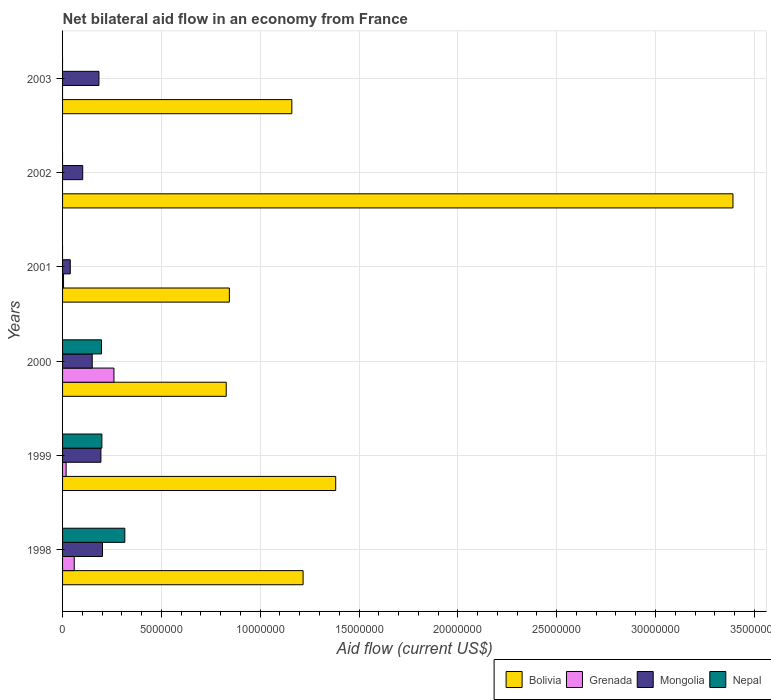How many groups of bars are there?
Give a very brief answer. 6. Are the number of bars per tick equal to the number of legend labels?
Ensure brevity in your answer.  No. How many bars are there on the 3rd tick from the top?
Keep it short and to the point. 3. Across all years, what is the maximum net bilateral aid flow in Grenada?
Keep it short and to the point. 2.60e+06. Across all years, what is the minimum net bilateral aid flow in Bolivia?
Offer a terse response. 8.28e+06. What is the total net bilateral aid flow in Bolivia in the graph?
Give a very brief answer. 8.82e+07. What is the difference between the net bilateral aid flow in Grenada in 1998 and the net bilateral aid flow in Nepal in 2003?
Keep it short and to the point. 5.90e+05. What is the average net bilateral aid flow in Nepal per year?
Provide a succinct answer. 1.18e+06. In the year 2002, what is the difference between the net bilateral aid flow in Bolivia and net bilateral aid flow in Mongolia?
Ensure brevity in your answer.  3.29e+07. In how many years, is the net bilateral aid flow in Grenada greater than 18000000 US$?
Offer a terse response. 0. What is the ratio of the net bilateral aid flow in Mongolia in 1998 to that in 2003?
Give a very brief answer. 1.1. Is the net bilateral aid flow in Mongolia in 2002 less than that in 2003?
Give a very brief answer. Yes. What is the difference between the highest and the second highest net bilateral aid flow in Bolivia?
Make the answer very short. 2.01e+07. What is the difference between the highest and the lowest net bilateral aid flow in Bolivia?
Your response must be concise. 2.56e+07. In how many years, is the net bilateral aid flow in Mongolia greater than the average net bilateral aid flow in Mongolia taken over all years?
Your response must be concise. 4. Is the sum of the net bilateral aid flow in Grenada in 1998 and 2001 greater than the maximum net bilateral aid flow in Bolivia across all years?
Give a very brief answer. No. Is it the case that in every year, the sum of the net bilateral aid flow in Mongolia and net bilateral aid flow in Nepal is greater than the sum of net bilateral aid flow in Bolivia and net bilateral aid flow in Grenada?
Your response must be concise. No. How many bars are there?
Your response must be concise. 19. Are all the bars in the graph horizontal?
Your answer should be compact. Yes. What is the difference between two consecutive major ticks on the X-axis?
Your response must be concise. 5.00e+06. Does the graph contain any zero values?
Your answer should be compact. Yes. Does the graph contain grids?
Offer a very short reply. Yes. Where does the legend appear in the graph?
Provide a succinct answer. Bottom right. What is the title of the graph?
Keep it short and to the point. Net bilateral aid flow in an economy from France. What is the Aid flow (current US$) of Bolivia in 1998?
Provide a short and direct response. 1.22e+07. What is the Aid flow (current US$) of Grenada in 1998?
Offer a very short reply. 5.90e+05. What is the Aid flow (current US$) in Mongolia in 1998?
Ensure brevity in your answer.  2.02e+06. What is the Aid flow (current US$) in Nepal in 1998?
Offer a very short reply. 3.15e+06. What is the Aid flow (current US$) of Bolivia in 1999?
Your response must be concise. 1.38e+07. What is the Aid flow (current US$) in Mongolia in 1999?
Your response must be concise. 1.94e+06. What is the Aid flow (current US$) in Nepal in 1999?
Your response must be concise. 1.99e+06. What is the Aid flow (current US$) of Bolivia in 2000?
Provide a succinct answer. 8.28e+06. What is the Aid flow (current US$) in Grenada in 2000?
Give a very brief answer. 2.60e+06. What is the Aid flow (current US$) of Mongolia in 2000?
Your response must be concise. 1.50e+06. What is the Aid flow (current US$) of Nepal in 2000?
Offer a very short reply. 1.97e+06. What is the Aid flow (current US$) of Bolivia in 2001?
Provide a short and direct response. 8.44e+06. What is the Aid flow (current US$) in Grenada in 2001?
Give a very brief answer. 5.00e+04. What is the Aid flow (current US$) of Mongolia in 2001?
Your answer should be compact. 3.90e+05. What is the Aid flow (current US$) of Bolivia in 2002?
Your answer should be compact. 3.39e+07. What is the Aid flow (current US$) in Grenada in 2002?
Keep it short and to the point. 0. What is the Aid flow (current US$) in Mongolia in 2002?
Keep it short and to the point. 1.02e+06. What is the Aid flow (current US$) in Bolivia in 2003?
Give a very brief answer. 1.16e+07. What is the Aid flow (current US$) in Grenada in 2003?
Give a very brief answer. 0. What is the Aid flow (current US$) of Mongolia in 2003?
Ensure brevity in your answer.  1.84e+06. Across all years, what is the maximum Aid flow (current US$) in Bolivia?
Your answer should be compact. 3.39e+07. Across all years, what is the maximum Aid flow (current US$) of Grenada?
Ensure brevity in your answer.  2.60e+06. Across all years, what is the maximum Aid flow (current US$) of Mongolia?
Make the answer very short. 2.02e+06. Across all years, what is the maximum Aid flow (current US$) of Nepal?
Ensure brevity in your answer.  3.15e+06. Across all years, what is the minimum Aid flow (current US$) in Bolivia?
Keep it short and to the point. 8.28e+06. Across all years, what is the minimum Aid flow (current US$) of Mongolia?
Give a very brief answer. 3.90e+05. What is the total Aid flow (current US$) in Bolivia in the graph?
Give a very brief answer. 8.82e+07. What is the total Aid flow (current US$) of Grenada in the graph?
Provide a succinct answer. 3.42e+06. What is the total Aid flow (current US$) of Mongolia in the graph?
Offer a very short reply. 8.71e+06. What is the total Aid flow (current US$) of Nepal in the graph?
Your answer should be compact. 7.11e+06. What is the difference between the Aid flow (current US$) of Bolivia in 1998 and that in 1999?
Your response must be concise. -1.65e+06. What is the difference between the Aid flow (current US$) in Mongolia in 1998 and that in 1999?
Provide a short and direct response. 8.00e+04. What is the difference between the Aid flow (current US$) of Nepal in 1998 and that in 1999?
Your response must be concise. 1.16e+06. What is the difference between the Aid flow (current US$) in Bolivia in 1998 and that in 2000?
Your answer should be compact. 3.89e+06. What is the difference between the Aid flow (current US$) of Grenada in 1998 and that in 2000?
Offer a very short reply. -2.01e+06. What is the difference between the Aid flow (current US$) in Mongolia in 1998 and that in 2000?
Provide a succinct answer. 5.20e+05. What is the difference between the Aid flow (current US$) in Nepal in 1998 and that in 2000?
Provide a succinct answer. 1.18e+06. What is the difference between the Aid flow (current US$) in Bolivia in 1998 and that in 2001?
Ensure brevity in your answer.  3.73e+06. What is the difference between the Aid flow (current US$) in Grenada in 1998 and that in 2001?
Offer a terse response. 5.40e+05. What is the difference between the Aid flow (current US$) in Mongolia in 1998 and that in 2001?
Keep it short and to the point. 1.63e+06. What is the difference between the Aid flow (current US$) in Bolivia in 1998 and that in 2002?
Your answer should be very brief. -2.18e+07. What is the difference between the Aid flow (current US$) in Mongolia in 1998 and that in 2002?
Give a very brief answer. 1.00e+06. What is the difference between the Aid flow (current US$) of Bolivia in 1998 and that in 2003?
Offer a terse response. 5.70e+05. What is the difference between the Aid flow (current US$) of Bolivia in 1999 and that in 2000?
Ensure brevity in your answer.  5.54e+06. What is the difference between the Aid flow (current US$) in Grenada in 1999 and that in 2000?
Offer a terse response. -2.42e+06. What is the difference between the Aid flow (current US$) in Nepal in 1999 and that in 2000?
Your answer should be compact. 2.00e+04. What is the difference between the Aid flow (current US$) in Bolivia in 1999 and that in 2001?
Give a very brief answer. 5.38e+06. What is the difference between the Aid flow (current US$) of Mongolia in 1999 and that in 2001?
Your response must be concise. 1.55e+06. What is the difference between the Aid flow (current US$) of Bolivia in 1999 and that in 2002?
Provide a succinct answer. -2.01e+07. What is the difference between the Aid flow (current US$) of Mongolia in 1999 and that in 2002?
Keep it short and to the point. 9.20e+05. What is the difference between the Aid flow (current US$) in Bolivia in 1999 and that in 2003?
Your response must be concise. 2.22e+06. What is the difference between the Aid flow (current US$) of Bolivia in 2000 and that in 2001?
Keep it short and to the point. -1.60e+05. What is the difference between the Aid flow (current US$) in Grenada in 2000 and that in 2001?
Keep it short and to the point. 2.55e+06. What is the difference between the Aid flow (current US$) of Mongolia in 2000 and that in 2001?
Offer a terse response. 1.11e+06. What is the difference between the Aid flow (current US$) of Bolivia in 2000 and that in 2002?
Make the answer very short. -2.56e+07. What is the difference between the Aid flow (current US$) in Mongolia in 2000 and that in 2002?
Ensure brevity in your answer.  4.80e+05. What is the difference between the Aid flow (current US$) in Bolivia in 2000 and that in 2003?
Your answer should be compact. -3.32e+06. What is the difference between the Aid flow (current US$) of Bolivia in 2001 and that in 2002?
Keep it short and to the point. -2.55e+07. What is the difference between the Aid flow (current US$) of Mongolia in 2001 and that in 2002?
Offer a terse response. -6.30e+05. What is the difference between the Aid flow (current US$) in Bolivia in 2001 and that in 2003?
Give a very brief answer. -3.16e+06. What is the difference between the Aid flow (current US$) of Mongolia in 2001 and that in 2003?
Ensure brevity in your answer.  -1.45e+06. What is the difference between the Aid flow (current US$) of Bolivia in 2002 and that in 2003?
Keep it short and to the point. 2.23e+07. What is the difference between the Aid flow (current US$) in Mongolia in 2002 and that in 2003?
Ensure brevity in your answer.  -8.20e+05. What is the difference between the Aid flow (current US$) of Bolivia in 1998 and the Aid flow (current US$) of Grenada in 1999?
Provide a succinct answer. 1.20e+07. What is the difference between the Aid flow (current US$) in Bolivia in 1998 and the Aid flow (current US$) in Mongolia in 1999?
Provide a short and direct response. 1.02e+07. What is the difference between the Aid flow (current US$) in Bolivia in 1998 and the Aid flow (current US$) in Nepal in 1999?
Your answer should be very brief. 1.02e+07. What is the difference between the Aid flow (current US$) in Grenada in 1998 and the Aid flow (current US$) in Mongolia in 1999?
Ensure brevity in your answer.  -1.35e+06. What is the difference between the Aid flow (current US$) in Grenada in 1998 and the Aid flow (current US$) in Nepal in 1999?
Ensure brevity in your answer.  -1.40e+06. What is the difference between the Aid flow (current US$) in Mongolia in 1998 and the Aid flow (current US$) in Nepal in 1999?
Give a very brief answer. 3.00e+04. What is the difference between the Aid flow (current US$) in Bolivia in 1998 and the Aid flow (current US$) in Grenada in 2000?
Provide a succinct answer. 9.57e+06. What is the difference between the Aid flow (current US$) in Bolivia in 1998 and the Aid flow (current US$) in Mongolia in 2000?
Your answer should be very brief. 1.07e+07. What is the difference between the Aid flow (current US$) in Bolivia in 1998 and the Aid flow (current US$) in Nepal in 2000?
Your answer should be very brief. 1.02e+07. What is the difference between the Aid flow (current US$) of Grenada in 1998 and the Aid flow (current US$) of Mongolia in 2000?
Your answer should be very brief. -9.10e+05. What is the difference between the Aid flow (current US$) of Grenada in 1998 and the Aid flow (current US$) of Nepal in 2000?
Your response must be concise. -1.38e+06. What is the difference between the Aid flow (current US$) in Mongolia in 1998 and the Aid flow (current US$) in Nepal in 2000?
Ensure brevity in your answer.  5.00e+04. What is the difference between the Aid flow (current US$) of Bolivia in 1998 and the Aid flow (current US$) of Grenada in 2001?
Provide a succinct answer. 1.21e+07. What is the difference between the Aid flow (current US$) of Bolivia in 1998 and the Aid flow (current US$) of Mongolia in 2001?
Ensure brevity in your answer.  1.18e+07. What is the difference between the Aid flow (current US$) in Bolivia in 1998 and the Aid flow (current US$) in Mongolia in 2002?
Your answer should be very brief. 1.12e+07. What is the difference between the Aid flow (current US$) of Grenada in 1998 and the Aid flow (current US$) of Mongolia in 2002?
Keep it short and to the point. -4.30e+05. What is the difference between the Aid flow (current US$) in Bolivia in 1998 and the Aid flow (current US$) in Mongolia in 2003?
Offer a terse response. 1.03e+07. What is the difference between the Aid flow (current US$) of Grenada in 1998 and the Aid flow (current US$) of Mongolia in 2003?
Your response must be concise. -1.25e+06. What is the difference between the Aid flow (current US$) in Bolivia in 1999 and the Aid flow (current US$) in Grenada in 2000?
Give a very brief answer. 1.12e+07. What is the difference between the Aid flow (current US$) of Bolivia in 1999 and the Aid flow (current US$) of Mongolia in 2000?
Make the answer very short. 1.23e+07. What is the difference between the Aid flow (current US$) of Bolivia in 1999 and the Aid flow (current US$) of Nepal in 2000?
Offer a very short reply. 1.18e+07. What is the difference between the Aid flow (current US$) in Grenada in 1999 and the Aid flow (current US$) in Mongolia in 2000?
Your answer should be compact. -1.32e+06. What is the difference between the Aid flow (current US$) of Grenada in 1999 and the Aid flow (current US$) of Nepal in 2000?
Your response must be concise. -1.79e+06. What is the difference between the Aid flow (current US$) in Bolivia in 1999 and the Aid flow (current US$) in Grenada in 2001?
Provide a short and direct response. 1.38e+07. What is the difference between the Aid flow (current US$) in Bolivia in 1999 and the Aid flow (current US$) in Mongolia in 2001?
Your answer should be very brief. 1.34e+07. What is the difference between the Aid flow (current US$) in Bolivia in 1999 and the Aid flow (current US$) in Mongolia in 2002?
Your response must be concise. 1.28e+07. What is the difference between the Aid flow (current US$) of Grenada in 1999 and the Aid flow (current US$) of Mongolia in 2002?
Your answer should be compact. -8.40e+05. What is the difference between the Aid flow (current US$) of Bolivia in 1999 and the Aid flow (current US$) of Mongolia in 2003?
Your answer should be very brief. 1.20e+07. What is the difference between the Aid flow (current US$) of Grenada in 1999 and the Aid flow (current US$) of Mongolia in 2003?
Offer a terse response. -1.66e+06. What is the difference between the Aid flow (current US$) in Bolivia in 2000 and the Aid flow (current US$) in Grenada in 2001?
Provide a short and direct response. 8.23e+06. What is the difference between the Aid flow (current US$) in Bolivia in 2000 and the Aid flow (current US$) in Mongolia in 2001?
Provide a short and direct response. 7.89e+06. What is the difference between the Aid flow (current US$) of Grenada in 2000 and the Aid flow (current US$) of Mongolia in 2001?
Offer a terse response. 2.21e+06. What is the difference between the Aid flow (current US$) in Bolivia in 2000 and the Aid flow (current US$) in Mongolia in 2002?
Offer a very short reply. 7.26e+06. What is the difference between the Aid flow (current US$) of Grenada in 2000 and the Aid flow (current US$) of Mongolia in 2002?
Your answer should be very brief. 1.58e+06. What is the difference between the Aid flow (current US$) in Bolivia in 2000 and the Aid flow (current US$) in Mongolia in 2003?
Offer a terse response. 6.44e+06. What is the difference between the Aid flow (current US$) in Grenada in 2000 and the Aid flow (current US$) in Mongolia in 2003?
Your answer should be compact. 7.60e+05. What is the difference between the Aid flow (current US$) of Bolivia in 2001 and the Aid flow (current US$) of Mongolia in 2002?
Provide a short and direct response. 7.42e+06. What is the difference between the Aid flow (current US$) of Grenada in 2001 and the Aid flow (current US$) of Mongolia in 2002?
Make the answer very short. -9.70e+05. What is the difference between the Aid flow (current US$) in Bolivia in 2001 and the Aid flow (current US$) in Mongolia in 2003?
Your answer should be compact. 6.60e+06. What is the difference between the Aid flow (current US$) of Grenada in 2001 and the Aid flow (current US$) of Mongolia in 2003?
Give a very brief answer. -1.79e+06. What is the difference between the Aid flow (current US$) of Bolivia in 2002 and the Aid flow (current US$) of Mongolia in 2003?
Provide a succinct answer. 3.21e+07. What is the average Aid flow (current US$) of Bolivia per year?
Offer a very short reply. 1.47e+07. What is the average Aid flow (current US$) of Grenada per year?
Your answer should be compact. 5.70e+05. What is the average Aid flow (current US$) in Mongolia per year?
Keep it short and to the point. 1.45e+06. What is the average Aid flow (current US$) in Nepal per year?
Make the answer very short. 1.18e+06. In the year 1998, what is the difference between the Aid flow (current US$) of Bolivia and Aid flow (current US$) of Grenada?
Make the answer very short. 1.16e+07. In the year 1998, what is the difference between the Aid flow (current US$) of Bolivia and Aid flow (current US$) of Mongolia?
Your answer should be very brief. 1.02e+07. In the year 1998, what is the difference between the Aid flow (current US$) of Bolivia and Aid flow (current US$) of Nepal?
Ensure brevity in your answer.  9.02e+06. In the year 1998, what is the difference between the Aid flow (current US$) of Grenada and Aid flow (current US$) of Mongolia?
Ensure brevity in your answer.  -1.43e+06. In the year 1998, what is the difference between the Aid flow (current US$) in Grenada and Aid flow (current US$) in Nepal?
Make the answer very short. -2.56e+06. In the year 1998, what is the difference between the Aid flow (current US$) of Mongolia and Aid flow (current US$) of Nepal?
Your answer should be very brief. -1.13e+06. In the year 1999, what is the difference between the Aid flow (current US$) of Bolivia and Aid flow (current US$) of Grenada?
Provide a succinct answer. 1.36e+07. In the year 1999, what is the difference between the Aid flow (current US$) in Bolivia and Aid flow (current US$) in Mongolia?
Ensure brevity in your answer.  1.19e+07. In the year 1999, what is the difference between the Aid flow (current US$) in Bolivia and Aid flow (current US$) in Nepal?
Give a very brief answer. 1.18e+07. In the year 1999, what is the difference between the Aid flow (current US$) of Grenada and Aid flow (current US$) of Mongolia?
Offer a terse response. -1.76e+06. In the year 1999, what is the difference between the Aid flow (current US$) of Grenada and Aid flow (current US$) of Nepal?
Your response must be concise. -1.81e+06. In the year 1999, what is the difference between the Aid flow (current US$) in Mongolia and Aid flow (current US$) in Nepal?
Give a very brief answer. -5.00e+04. In the year 2000, what is the difference between the Aid flow (current US$) of Bolivia and Aid flow (current US$) of Grenada?
Offer a terse response. 5.68e+06. In the year 2000, what is the difference between the Aid flow (current US$) of Bolivia and Aid flow (current US$) of Mongolia?
Your answer should be very brief. 6.78e+06. In the year 2000, what is the difference between the Aid flow (current US$) in Bolivia and Aid flow (current US$) in Nepal?
Offer a terse response. 6.31e+06. In the year 2000, what is the difference between the Aid flow (current US$) in Grenada and Aid flow (current US$) in Mongolia?
Your response must be concise. 1.10e+06. In the year 2000, what is the difference between the Aid flow (current US$) in Grenada and Aid flow (current US$) in Nepal?
Offer a terse response. 6.30e+05. In the year 2000, what is the difference between the Aid flow (current US$) in Mongolia and Aid flow (current US$) in Nepal?
Offer a very short reply. -4.70e+05. In the year 2001, what is the difference between the Aid flow (current US$) of Bolivia and Aid flow (current US$) of Grenada?
Give a very brief answer. 8.39e+06. In the year 2001, what is the difference between the Aid flow (current US$) in Bolivia and Aid flow (current US$) in Mongolia?
Your answer should be compact. 8.05e+06. In the year 2002, what is the difference between the Aid flow (current US$) in Bolivia and Aid flow (current US$) in Mongolia?
Make the answer very short. 3.29e+07. In the year 2003, what is the difference between the Aid flow (current US$) in Bolivia and Aid flow (current US$) in Mongolia?
Ensure brevity in your answer.  9.76e+06. What is the ratio of the Aid flow (current US$) of Bolivia in 1998 to that in 1999?
Provide a succinct answer. 0.88. What is the ratio of the Aid flow (current US$) in Grenada in 1998 to that in 1999?
Keep it short and to the point. 3.28. What is the ratio of the Aid flow (current US$) in Mongolia in 1998 to that in 1999?
Your response must be concise. 1.04. What is the ratio of the Aid flow (current US$) in Nepal in 1998 to that in 1999?
Offer a terse response. 1.58. What is the ratio of the Aid flow (current US$) in Bolivia in 1998 to that in 2000?
Make the answer very short. 1.47. What is the ratio of the Aid flow (current US$) of Grenada in 1998 to that in 2000?
Your answer should be very brief. 0.23. What is the ratio of the Aid flow (current US$) in Mongolia in 1998 to that in 2000?
Offer a terse response. 1.35. What is the ratio of the Aid flow (current US$) of Nepal in 1998 to that in 2000?
Your response must be concise. 1.6. What is the ratio of the Aid flow (current US$) of Bolivia in 1998 to that in 2001?
Give a very brief answer. 1.44. What is the ratio of the Aid flow (current US$) in Grenada in 1998 to that in 2001?
Offer a very short reply. 11.8. What is the ratio of the Aid flow (current US$) in Mongolia in 1998 to that in 2001?
Provide a succinct answer. 5.18. What is the ratio of the Aid flow (current US$) in Bolivia in 1998 to that in 2002?
Ensure brevity in your answer.  0.36. What is the ratio of the Aid flow (current US$) of Mongolia in 1998 to that in 2002?
Your answer should be very brief. 1.98. What is the ratio of the Aid flow (current US$) of Bolivia in 1998 to that in 2003?
Make the answer very short. 1.05. What is the ratio of the Aid flow (current US$) in Mongolia in 1998 to that in 2003?
Provide a short and direct response. 1.1. What is the ratio of the Aid flow (current US$) in Bolivia in 1999 to that in 2000?
Your answer should be very brief. 1.67. What is the ratio of the Aid flow (current US$) in Grenada in 1999 to that in 2000?
Offer a very short reply. 0.07. What is the ratio of the Aid flow (current US$) of Mongolia in 1999 to that in 2000?
Provide a succinct answer. 1.29. What is the ratio of the Aid flow (current US$) of Nepal in 1999 to that in 2000?
Offer a very short reply. 1.01. What is the ratio of the Aid flow (current US$) in Bolivia in 1999 to that in 2001?
Provide a succinct answer. 1.64. What is the ratio of the Aid flow (current US$) of Mongolia in 1999 to that in 2001?
Offer a very short reply. 4.97. What is the ratio of the Aid flow (current US$) of Bolivia in 1999 to that in 2002?
Offer a very short reply. 0.41. What is the ratio of the Aid flow (current US$) in Mongolia in 1999 to that in 2002?
Keep it short and to the point. 1.9. What is the ratio of the Aid flow (current US$) of Bolivia in 1999 to that in 2003?
Offer a terse response. 1.19. What is the ratio of the Aid flow (current US$) of Mongolia in 1999 to that in 2003?
Your response must be concise. 1.05. What is the ratio of the Aid flow (current US$) in Grenada in 2000 to that in 2001?
Your answer should be compact. 52. What is the ratio of the Aid flow (current US$) of Mongolia in 2000 to that in 2001?
Give a very brief answer. 3.85. What is the ratio of the Aid flow (current US$) in Bolivia in 2000 to that in 2002?
Give a very brief answer. 0.24. What is the ratio of the Aid flow (current US$) in Mongolia in 2000 to that in 2002?
Your answer should be very brief. 1.47. What is the ratio of the Aid flow (current US$) of Bolivia in 2000 to that in 2003?
Offer a terse response. 0.71. What is the ratio of the Aid flow (current US$) in Mongolia in 2000 to that in 2003?
Provide a succinct answer. 0.82. What is the ratio of the Aid flow (current US$) in Bolivia in 2001 to that in 2002?
Your answer should be very brief. 0.25. What is the ratio of the Aid flow (current US$) of Mongolia in 2001 to that in 2002?
Ensure brevity in your answer.  0.38. What is the ratio of the Aid flow (current US$) in Bolivia in 2001 to that in 2003?
Your answer should be very brief. 0.73. What is the ratio of the Aid flow (current US$) in Mongolia in 2001 to that in 2003?
Your answer should be compact. 0.21. What is the ratio of the Aid flow (current US$) of Bolivia in 2002 to that in 2003?
Ensure brevity in your answer.  2.92. What is the ratio of the Aid flow (current US$) of Mongolia in 2002 to that in 2003?
Your answer should be very brief. 0.55. What is the difference between the highest and the second highest Aid flow (current US$) of Bolivia?
Give a very brief answer. 2.01e+07. What is the difference between the highest and the second highest Aid flow (current US$) of Grenada?
Your response must be concise. 2.01e+06. What is the difference between the highest and the second highest Aid flow (current US$) of Mongolia?
Give a very brief answer. 8.00e+04. What is the difference between the highest and the second highest Aid flow (current US$) in Nepal?
Offer a terse response. 1.16e+06. What is the difference between the highest and the lowest Aid flow (current US$) in Bolivia?
Your answer should be very brief. 2.56e+07. What is the difference between the highest and the lowest Aid flow (current US$) in Grenada?
Your answer should be very brief. 2.60e+06. What is the difference between the highest and the lowest Aid flow (current US$) in Mongolia?
Your answer should be compact. 1.63e+06. What is the difference between the highest and the lowest Aid flow (current US$) of Nepal?
Give a very brief answer. 3.15e+06. 